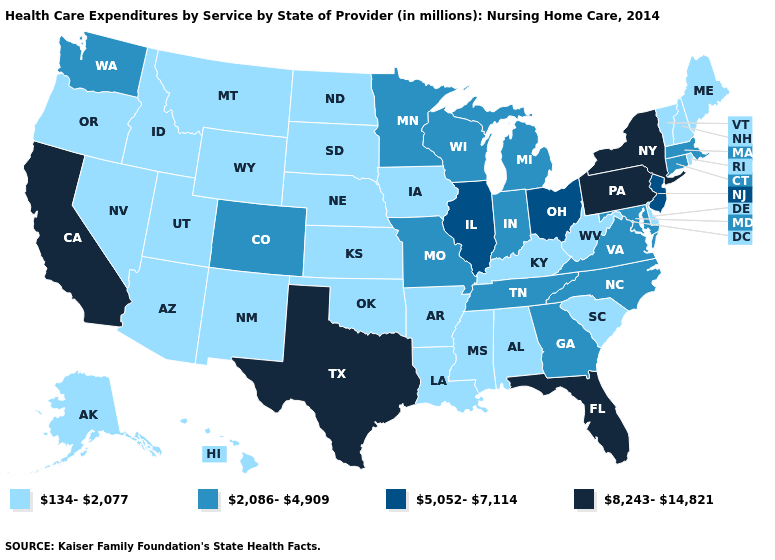What is the value of South Carolina?
Be succinct. 134-2,077. What is the lowest value in the West?
Give a very brief answer. 134-2,077. What is the value of Rhode Island?
Answer briefly. 134-2,077. Which states have the lowest value in the USA?
Quick response, please. Alabama, Alaska, Arizona, Arkansas, Delaware, Hawaii, Idaho, Iowa, Kansas, Kentucky, Louisiana, Maine, Mississippi, Montana, Nebraska, Nevada, New Hampshire, New Mexico, North Dakota, Oklahoma, Oregon, Rhode Island, South Carolina, South Dakota, Utah, Vermont, West Virginia, Wyoming. What is the value of South Carolina?
Concise answer only. 134-2,077. Does the map have missing data?
Concise answer only. No. What is the lowest value in the USA?
Write a very short answer. 134-2,077. Among the states that border Michigan , which have the lowest value?
Keep it brief. Indiana, Wisconsin. Name the states that have a value in the range 8,243-14,821?
Quick response, please. California, Florida, New York, Pennsylvania, Texas. What is the value of Arkansas?
Keep it brief. 134-2,077. What is the value of Minnesota?
Concise answer only. 2,086-4,909. What is the highest value in states that border Maine?
Answer briefly. 134-2,077. Name the states that have a value in the range 5,052-7,114?
Write a very short answer. Illinois, New Jersey, Ohio. Name the states that have a value in the range 2,086-4,909?
Quick response, please. Colorado, Connecticut, Georgia, Indiana, Maryland, Massachusetts, Michigan, Minnesota, Missouri, North Carolina, Tennessee, Virginia, Washington, Wisconsin. What is the value of Colorado?
Quick response, please. 2,086-4,909. 